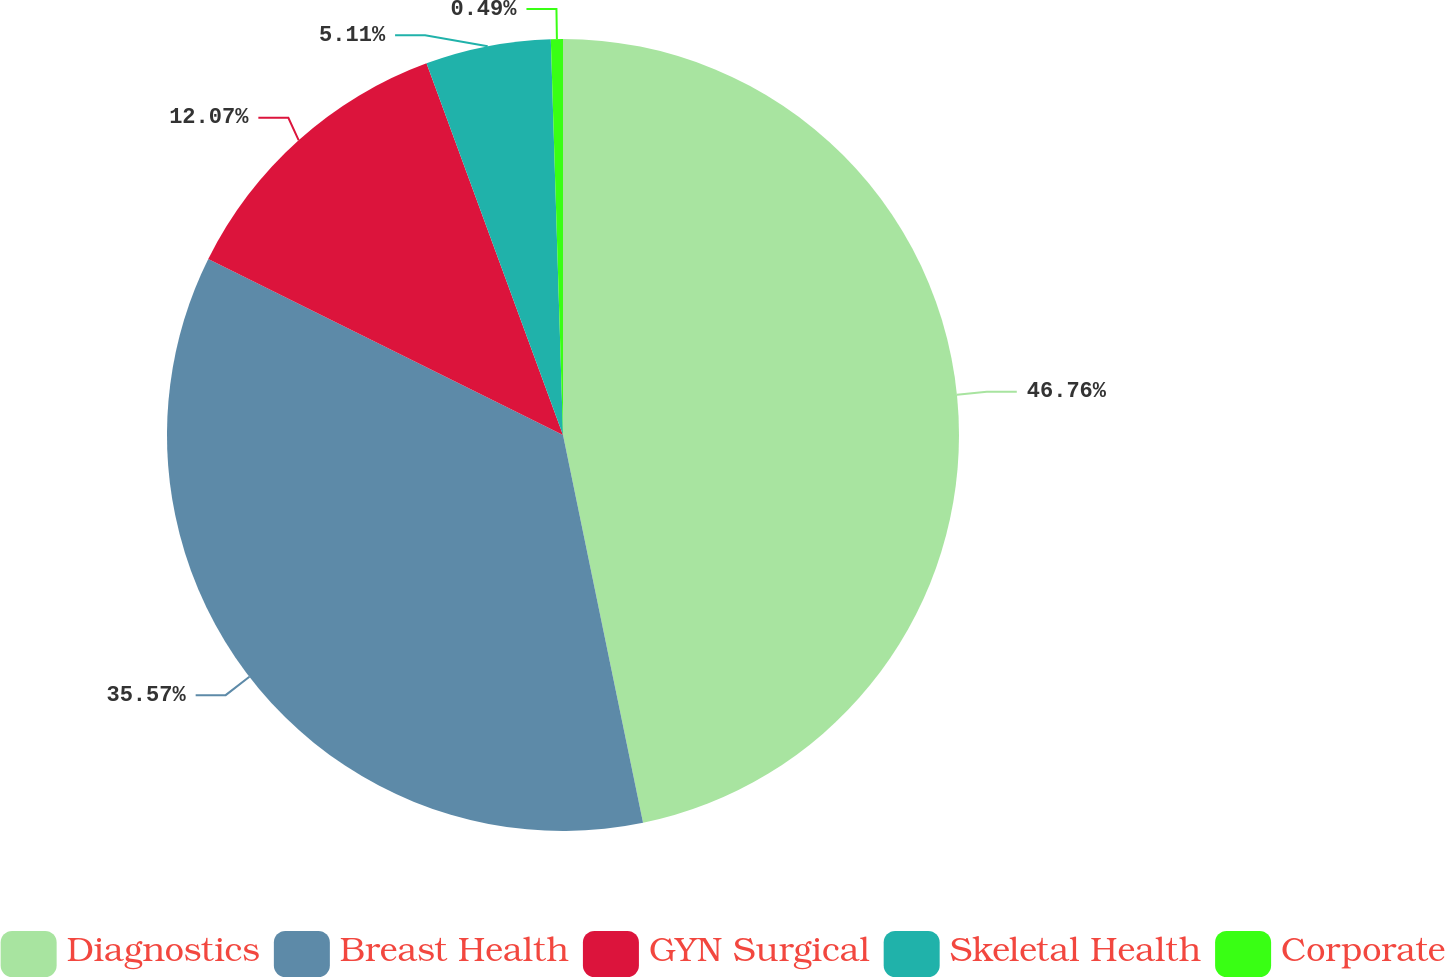<chart> <loc_0><loc_0><loc_500><loc_500><pie_chart><fcel>Diagnostics<fcel>Breast Health<fcel>GYN Surgical<fcel>Skeletal Health<fcel>Corporate<nl><fcel>46.76%<fcel>35.57%<fcel>12.07%<fcel>5.11%<fcel>0.49%<nl></chart> 